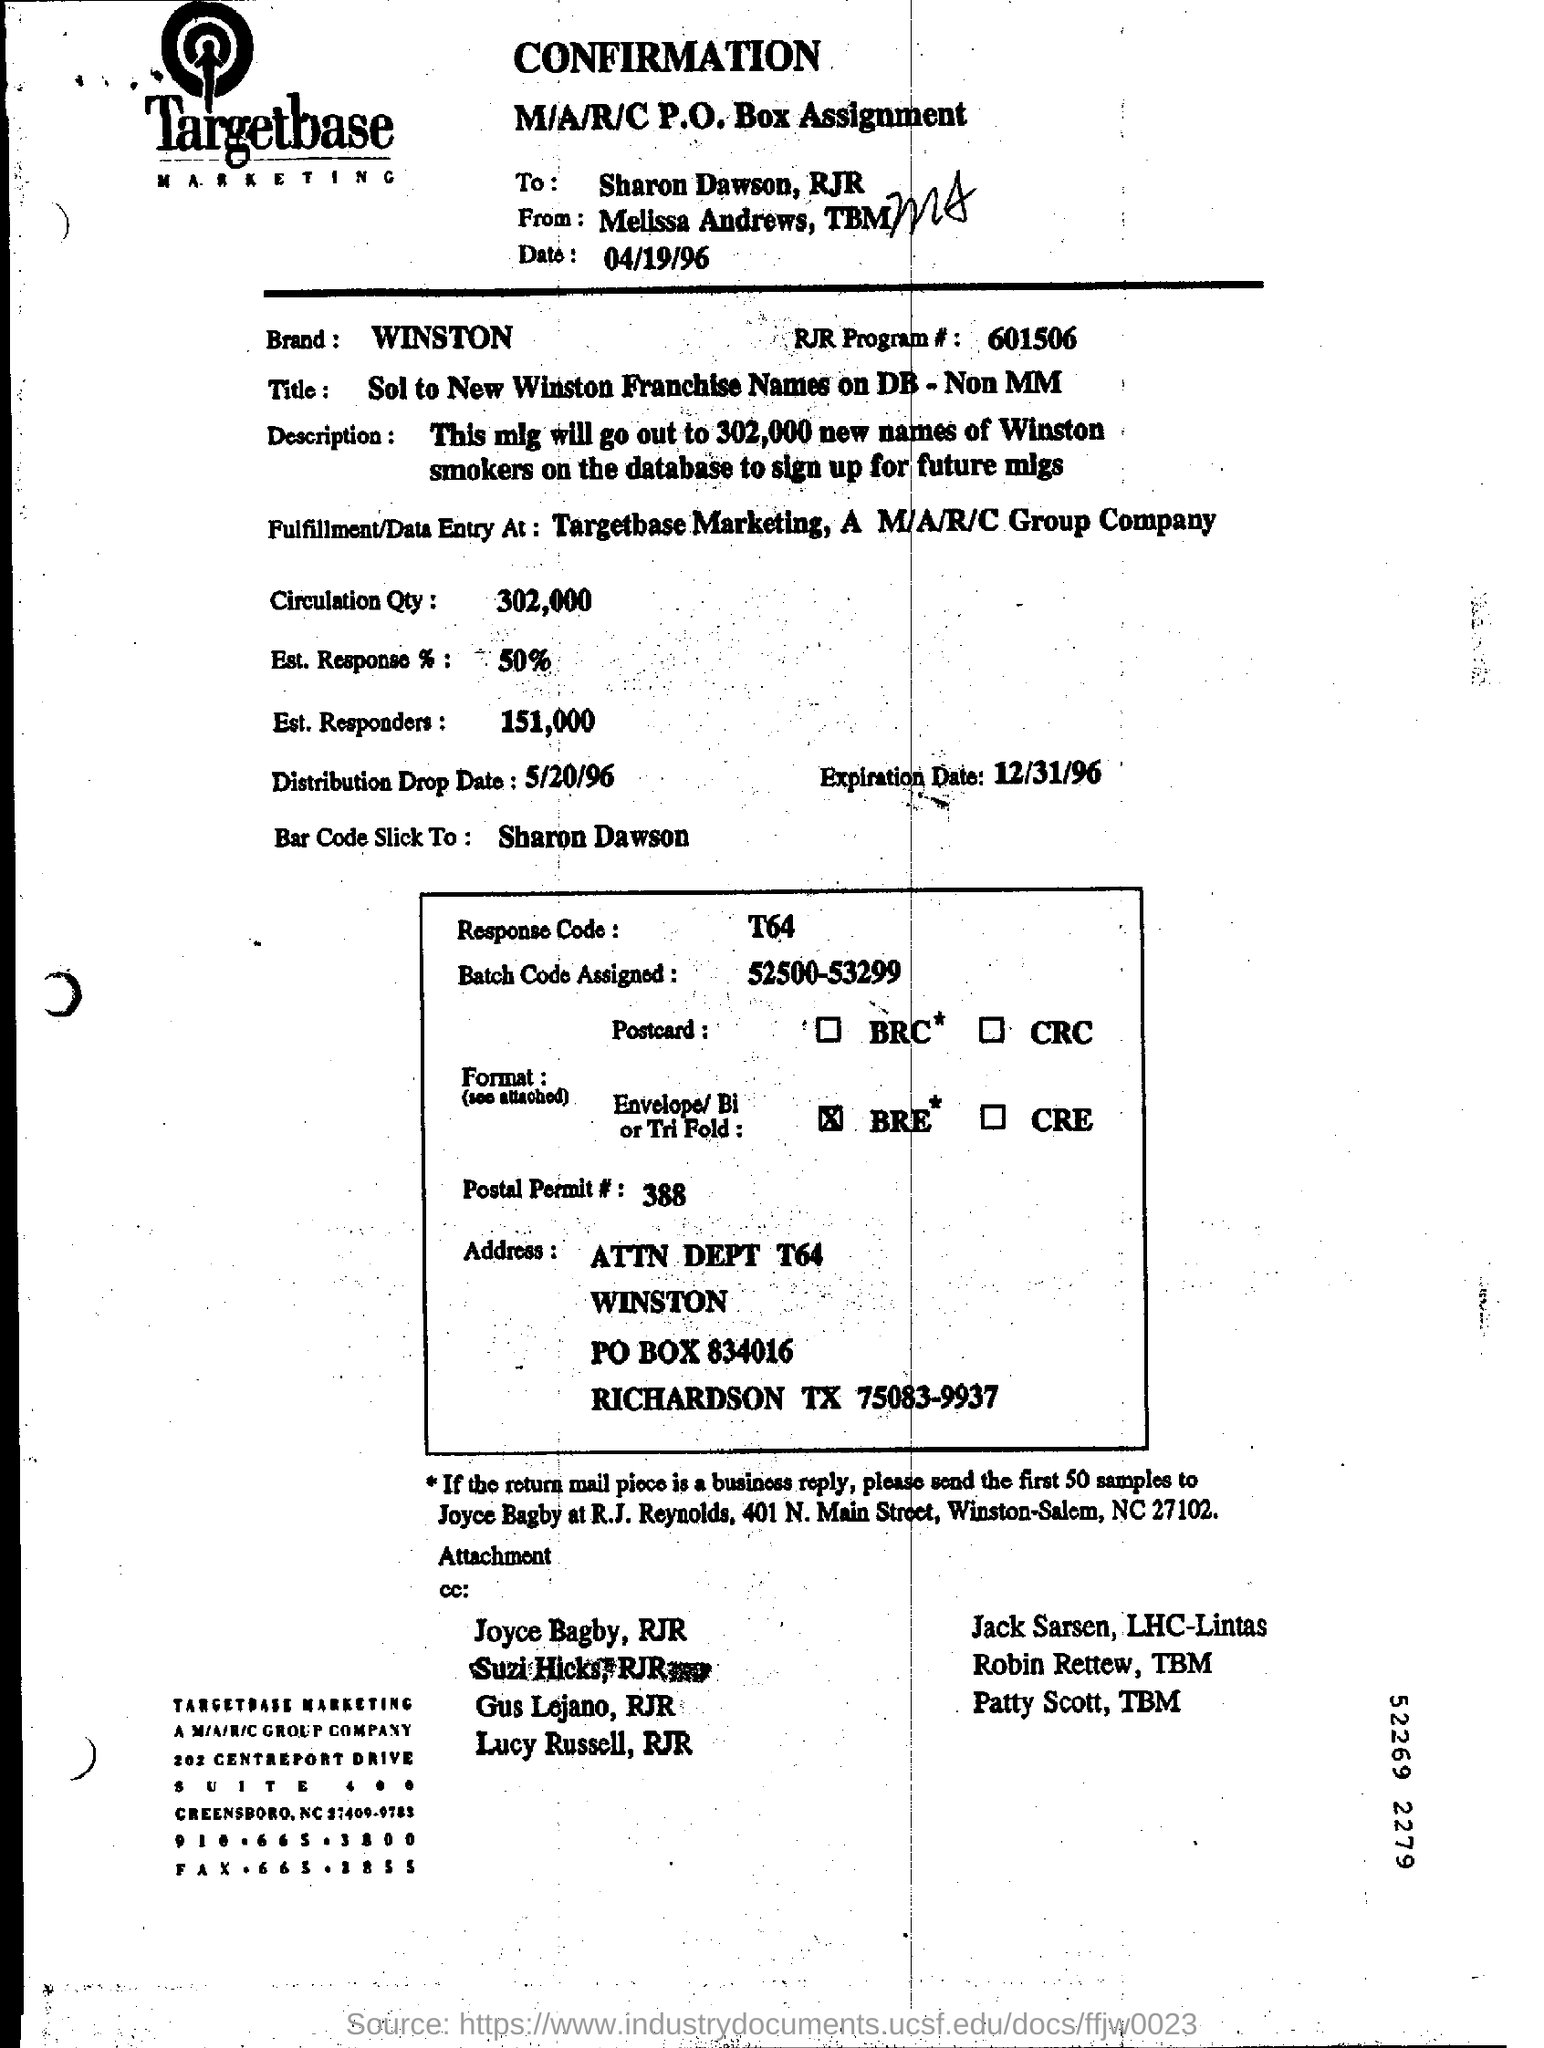What is the Est. Response %?
 50 